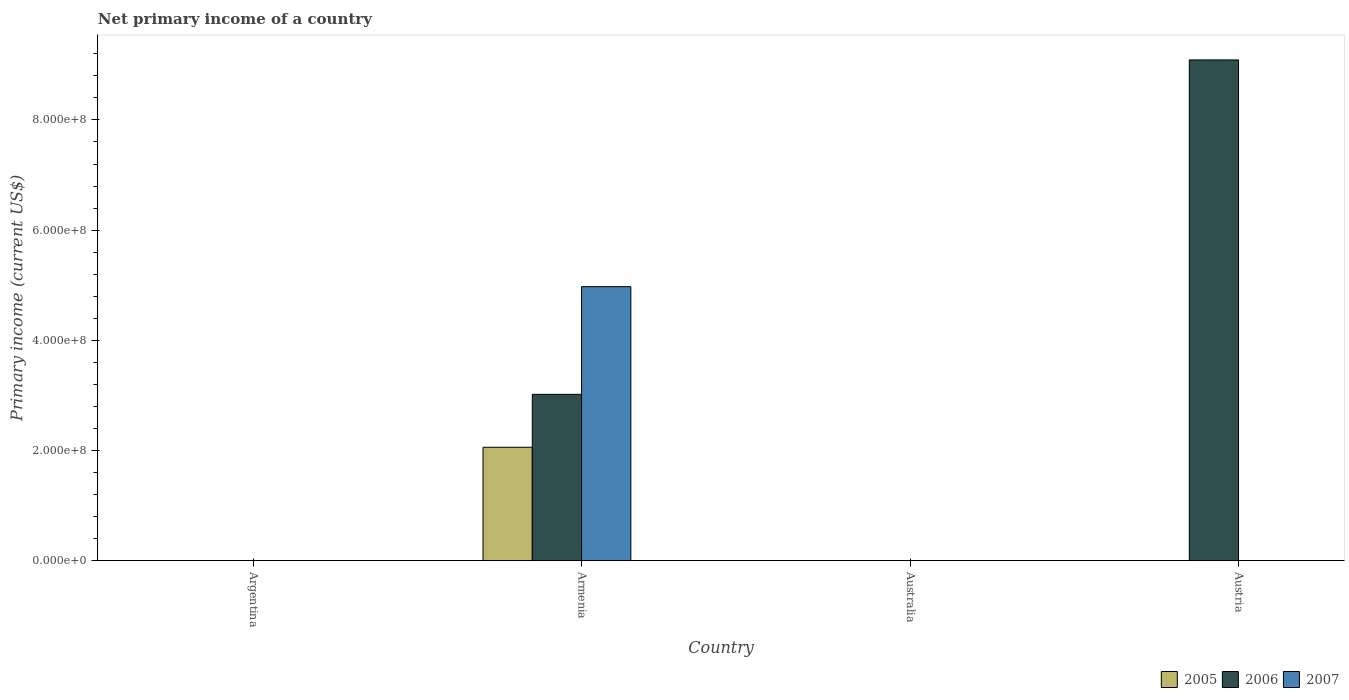How many different coloured bars are there?
Offer a terse response. 3. Are the number of bars on each tick of the X-axis equal?
Your response must be concise. No. How many bars are there on the 4th tick from the right?
Your answer should be very brief. 0. What is the label of the 3rd group of bars from the left?
Make the answer very short. Australia. Across all countries, what is the maximum primary income in 2007?
Provide a short and direct response. 4.97e+08. Across all countries, what is the minimum primary income in 2006?
Offer a terse response. 0. What is the total primary income in 2007 in the graph?
Make the answer very short. 4.97e+08. What is the average primary income in 2005 per country?
Offer a terse response. 5.15e+07. What is the difference between the primary income of/in 2006 and primary income of/in 2007 in Armenia?
Offer a very short reply. -1.95e+08. What is the difference between the highest and the lowest primary income in 2007?
Your answer should be compact. 4.97e+08. Is it the case that in every country, the sum of the primary income in 2005 and primary income in 2007 is greater than the primary income in 2006?
Make the answer very short. No. How many countries are there in the graph?
Your response must be concise. 4. What is the difference between two consecutive major ticks on the Y-axis?
Make the answer very short. 2.00e+08. How many legend labels are there?
Offer a terse response. 3. What is the title of the graph?
Provide a short and direct response. Net primary income of a country. What is the label or title of the X-axis?
Your answer should be very brief. Country. What is the label or title of the Y-axis?
Keep it short and to the point. Primary income (current US$). What is the Primary income (current US$) of 2005 in Argentina?
Your response must be concise. 0. What is the Primary income (current US$) in 2006 in Argentina?
Provide a succinct answer. 0. What is the Primary income (current US$) in 2005 in Armenia?
Keep it short and to the point. 2.06e+08. What is the Primary income (current US$) of 2006 in Armenia?
Give a very brief answer. 3.02e+08. What is the Primary income (current US$) of 2007 in Armenia?
Provide a succinct answer. 4.97e+08. What is the Primary income (current US$) of 2007 in Australia?
Make the answer very short. 0. What is the Primary income (current US$) in 2006 in Austria?
Your answer should be compact. 9.09e+08. What is the Primary income (current US$) of 2007 in Austria?
Ensure brevity in your answer.  0. Across all countries, what is the maximum Primary income (current US$) of 2005?
Provide a short and direct response. 2.06e+08. Across all countries, what is the maximum Primary income (current US$) in 2006?
Provide a succinct answer. 9.09e+08. Across all countries, what is the maximum Primary income (current US$) in 2007?
Provide a succinct answer. 4.97e+08. Across all countries, what is the minimum Primary income (current US$) of 2006?
Ensure brevity in your answer.  0. Across all countries, what is the minimum Primary income (current US$) of 2007?
Your answer should be very brief. 0. What is the total Primary income (current US$) in 2005 in the graph?
Make the answer very short. 2.06e+08. What is the total Primary income (current US$) of 2006 in the graph?
Provide a succinct answer. 1.21e+09. What is the total Primary income (current US$) in 2007 in the graph?
Your answer should be very brief. 4.97e+08. What is the difference between the Primary income (current US$) of 2006 in Armenia and that in Austria?
Provide a succinct answer. -6.07e+08. What is the difference between the Primary income (current US$) of 2005 in Armenia and the Primary income (current US$) of 2006 in Austria?
Keep it short and to the point. -7.03e+08. What is the average Primary income (current US$) of 2005 per country?
Ensure brevity in your answer.  5.15e+07. What is the average Primary income (current US$) in 2006 per country?
Your answer should be very brief. 3.03e+08. What is the average Primary income (current US$) in 2007 per country?
Offer a terse response. 1.24e+08. What is the difference between the Primary income (current US$) in 2005 and Primary income (current US$) in 2006 in Armenia?
Ensure brevity in your answer.  -9.60e+07. What is the difference between the Primary income (current US$) of 2005 and Primary income (current US$) of 2007 in Armenia?
Give a very brief answer. -2.91e+08. What is the difference between the Primary income (current US$) of 2006 and Primary income (current US$) of 2007 in Armenia?
Your answer should be compact. -1.95e+08. What is the ratio of the Primary income (current US$) in 2006 in Armenia to that in Austria?
Your answer should be compact. 0.33. What is the difference between the highest and the lowest Primary income (current US$) of 2005?
Give a very brief answer. 2.06e+08. What is the difference between the highest and the lowest Primary income (current US$) in 2006?
Ensure brevity in your answer.  9.09e+08. What is the difference between the highest and the lowest Primary income (current US$) in 2007?
Your answer should be very brief. 4.97e+08. 